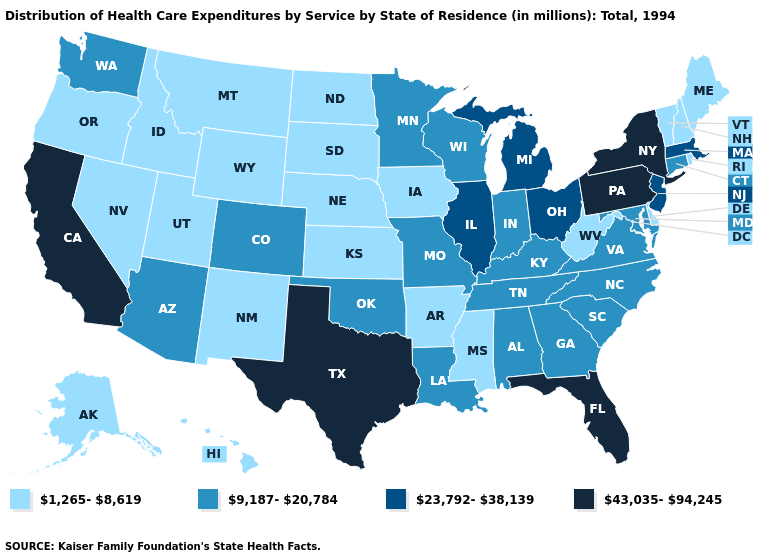What is the highest value in states that border Idaho?
Give a very brief answer. 9,187-20,784. Among the states that border Utah , which have the highest value?
Write a very short answer. Arizona, Colorado. What is the value of Rhode Island?
Concise answer only. 1,265-8,619. What is the highest value in the South ?
Quick response, please. 43,035-94,245. Name the states that have a value in the range 1,265-8,619?
Short answer required. Alaska, Arkansas, Delaware, Hawaii, Idaho, Iowa, Kansas, Maine, Mississippi, Montana, Nebraska, Nevada, New Hampshire, New Mexico, North Dakota, Oregon, Rhode Island, South Dakota, Utah, Vermont, West Virginia, Wyoming. Name the states that have a value in the range 43,035-94,245?
Short answer required. California, Florida, New York, Pennsylvania, Texas. What is the value of Pennsylvania?
Keep it brief. 43,035-94,245. Does Hawaii have the highest value in the USA?
Short answer required. No. Which states have the highest value in the USA?
Give a very brief answer. California, Florida, New York, Pennsylvania, Texas. Does Wisconsin have a lower value than Missouri?
Be succinct. No. Name the states that have a value in the range 1,265-8,619?
Concise answer only. Alaska, Arkansas, Delaware, Hawaii, Idaho, Iowa, Kansas, Maine, Mississippi, Montana, Nebraska, Nevada, New Hampshire, New Mexico, North Dakota, Oregon, Rhode Island, South Dakota, Utah, Vermont, West Virginia, Wyoming. What is the value of Iowa?
Short answer required. 1,265-8,619. 